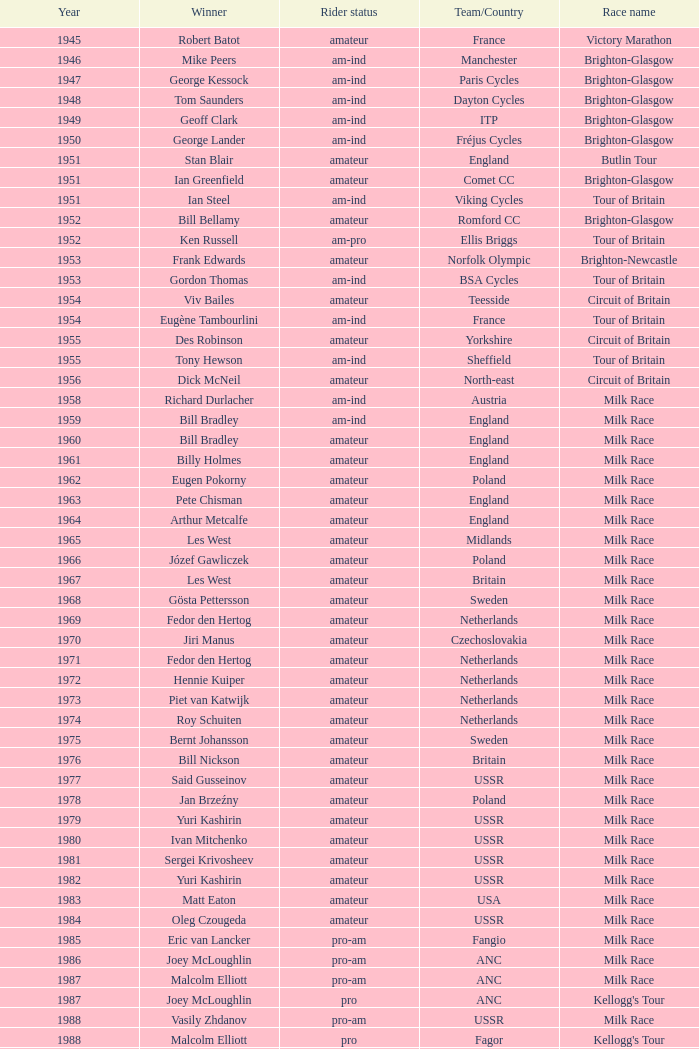Who was the winner in 1973 with an amateur rider status? Piet van Katwijk. 